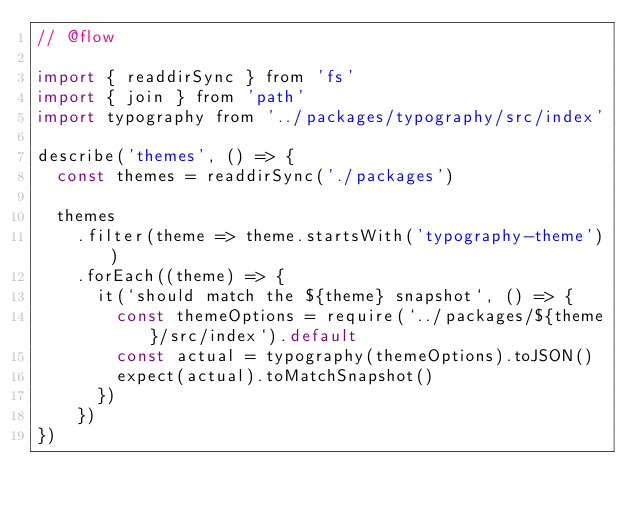<code> <loc_0><loc_0><loc_500><loc_500><_JavaScript_>// @flow

import { readdirSync } from 'fs'
import { join } from 'path'
import typography from '../packages/typography/src/index'

describe('themes', () => {
  const themes = readdirSync('./packages')

  themes
    .filter(theme => theme.startsWith('typography-theme'))
    .forEach((theme) => {
      it(`should match the ${theme} snapshot`, () => {
        const themeOptions = require(`../packages/${theme}/src/index`).default
        const actual = typography(themeOptions).toJSON()
        expect(actual).toMatchSnapshot()
      })
    })
})
</code> 